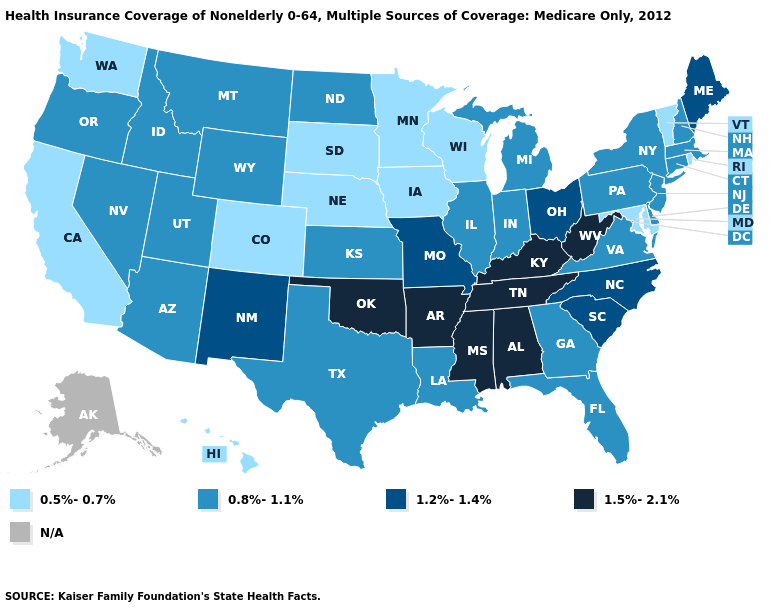Name the states that have a value in the range 1.2%-1.4%?
Give a very brief answer. Maine, Missouri, New Mexico, North Carolina, Ohio, South Carolina. Name the states that have a value in the range N/A?
Write a very short answer. Alaska. Among the states that border Kentucky , does West Virginia have the lowest value?
Concise answer only. No. What is the value of Massachusetts?
Answer briefly. 0.8%-1.1%. What is the highest value in states that border Connecticut?
Concise answer only. 0.8%-1.1%. Name the states that have a value in the range 1.5%-2.1%?
Write a very short answer. Alabama, Arkansas, Kentucky, Mississippi, Oklahoma, Tennessee, West Virginia. What is the value of Kansas?
Write a very short answer. 0.8%-1.1%. Which states have the lowest value in the USA?
Concise answer only. California, Colorado, Hawaii, Iowa, Maryland, Minnesota, Nebraska, Rhode Island, South Dakota, Vermont, Washington, Wisconsin. Name the states that have a value in the range N/A?
Quick response, please. Alaska. Name the states that have a value in the range 1.5%-2.1%?
Short answer required. Alabama, Arkansas, Kentucky, Mississippi, Oklahoma, Tennessee, West Virginia. What is the value of Minnesota?
Short answer required. 0.5%-0.7%. What is the value of Utah?
Write a very short answer. 0.8%-1.1%. What is the value of Iowa?
Short answer required. 0.5%-0.7%. What is the highest value in states that border Washington?
Answer briefly. 0.8%-1.1%. Name the states that have a value in the range 0.8%-1.1%?
Be succinct. Arizona, Connecticut, Delaware, Florida, Georgia, Idaho, Illinois, Indiana, Kansas, Louisiana, Massachusetts, Michigan, Montana, Nevada, New Hampshire, New Jersey, New York, North Dakota, Oregon, Pennsylvania, Texas, Utah, Virginia, Wyoming. 